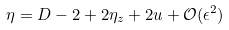Convert formula to latex. <formula><loc_0><loc_0><loc_500><loc_500>\eta = D - 2 + 2 \eta _ { z } + 2 u + \mathcal { O } ( \epsilon ^ { 2 } )</formula> 